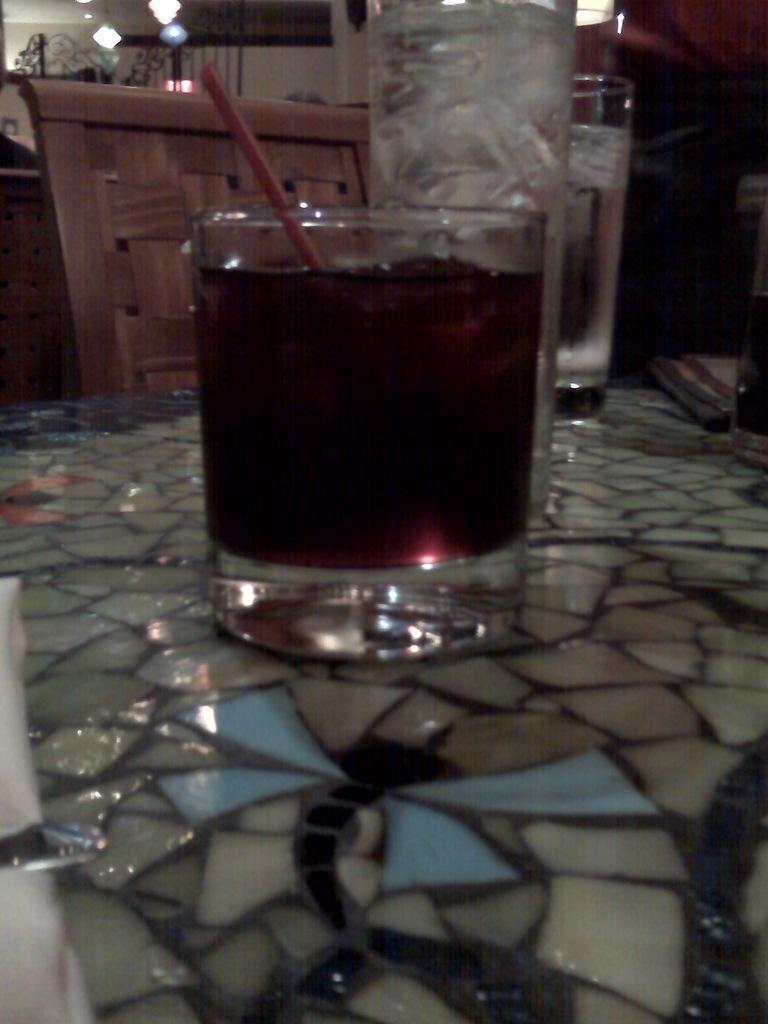Describe this image in one or two sentences. In this image there is a table towards the bottom of the image, there are glasses on the table, there is a straw, there is drink in the glass, there is a chair, there is an object towards the left of the image, there is an object towards the right of the image, there is wall, there are lights towards the top of the image. 